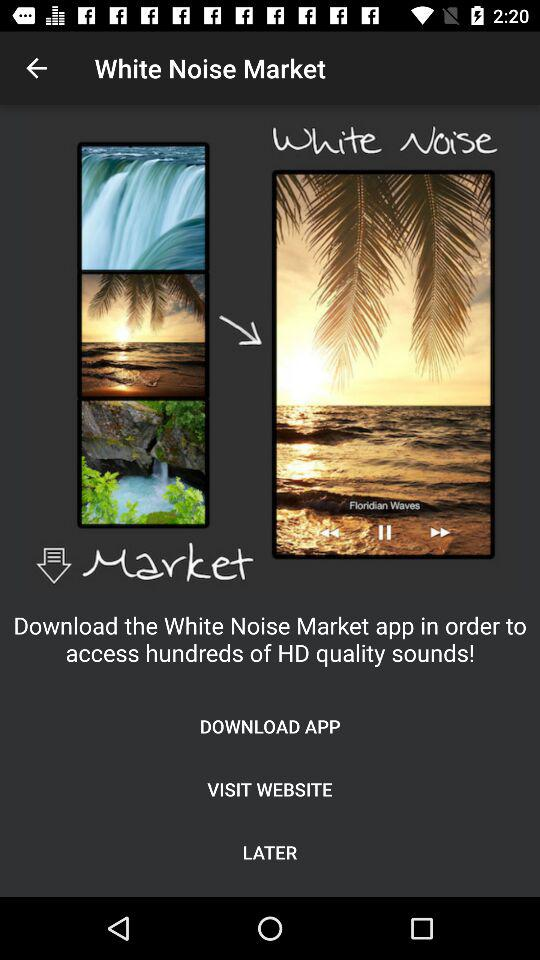What is application name? The application name is "White Noise Market". 